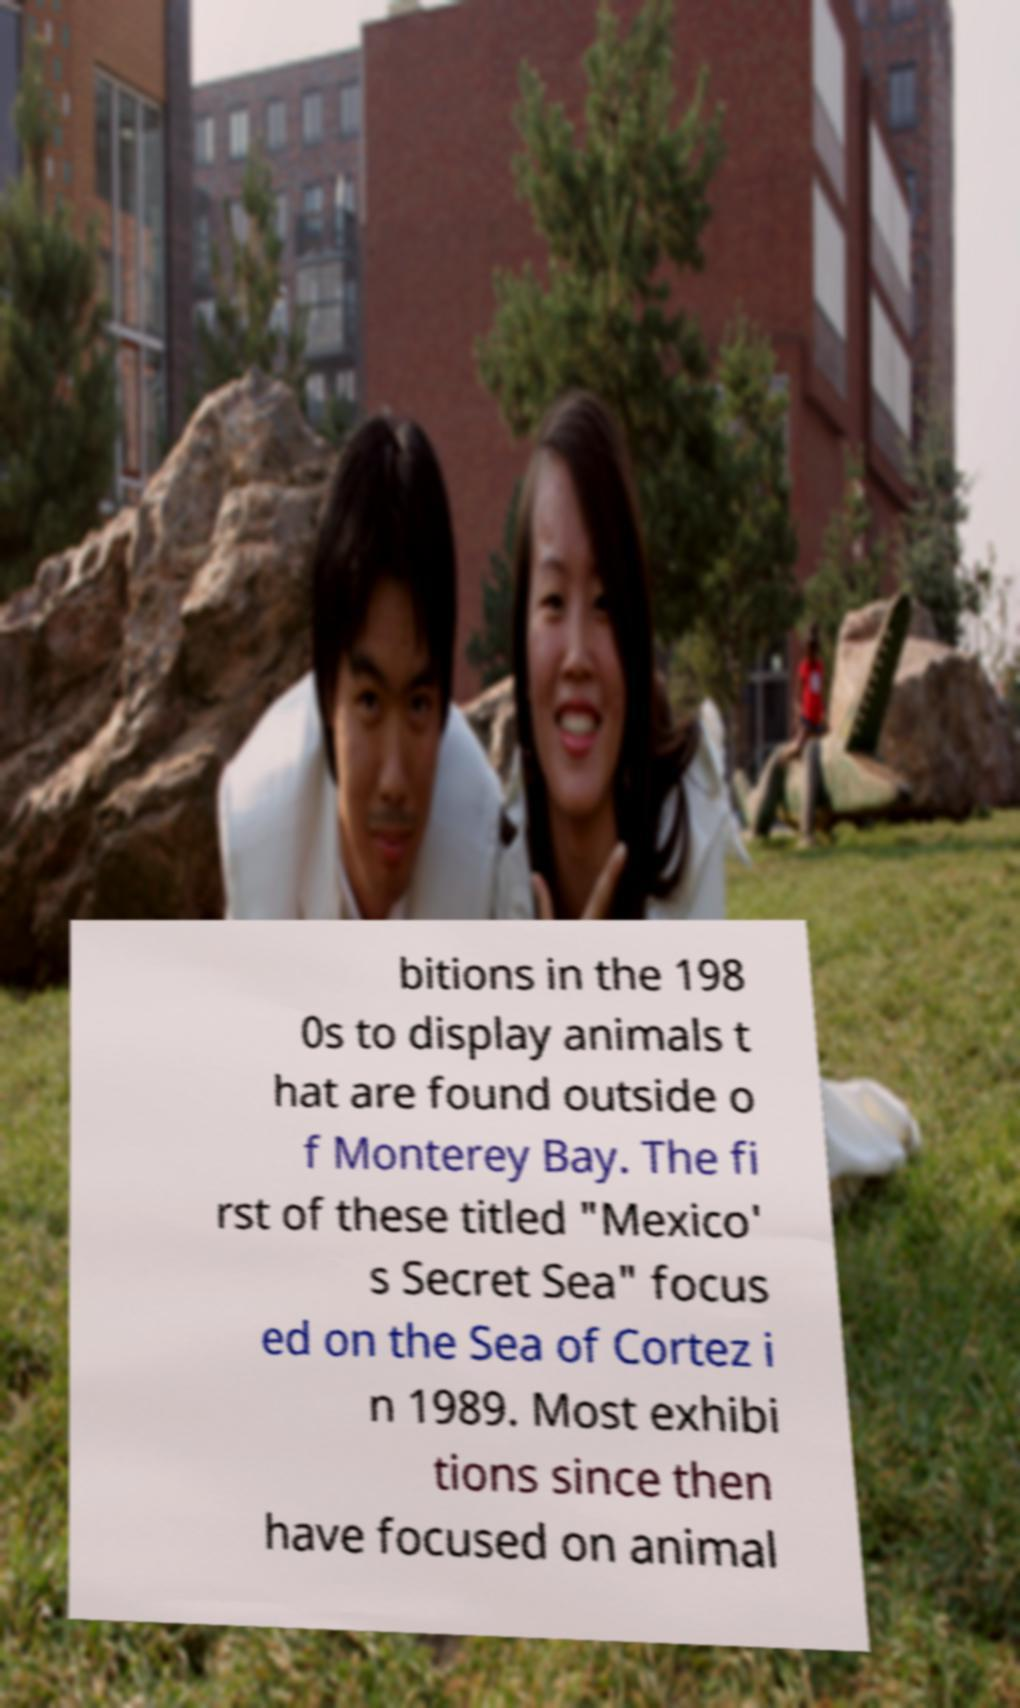For documentation purposes, I need the text within this image transcribed. Could you provide that? bitions in the 198 0s to display animals t hat are found outside o f Monterey Bay. The fi rst of these titled "Mexico' s Secret Sea" focus ed on the Sea of Cortez i n 1989. Most exhibi tions since then have focused on animal 